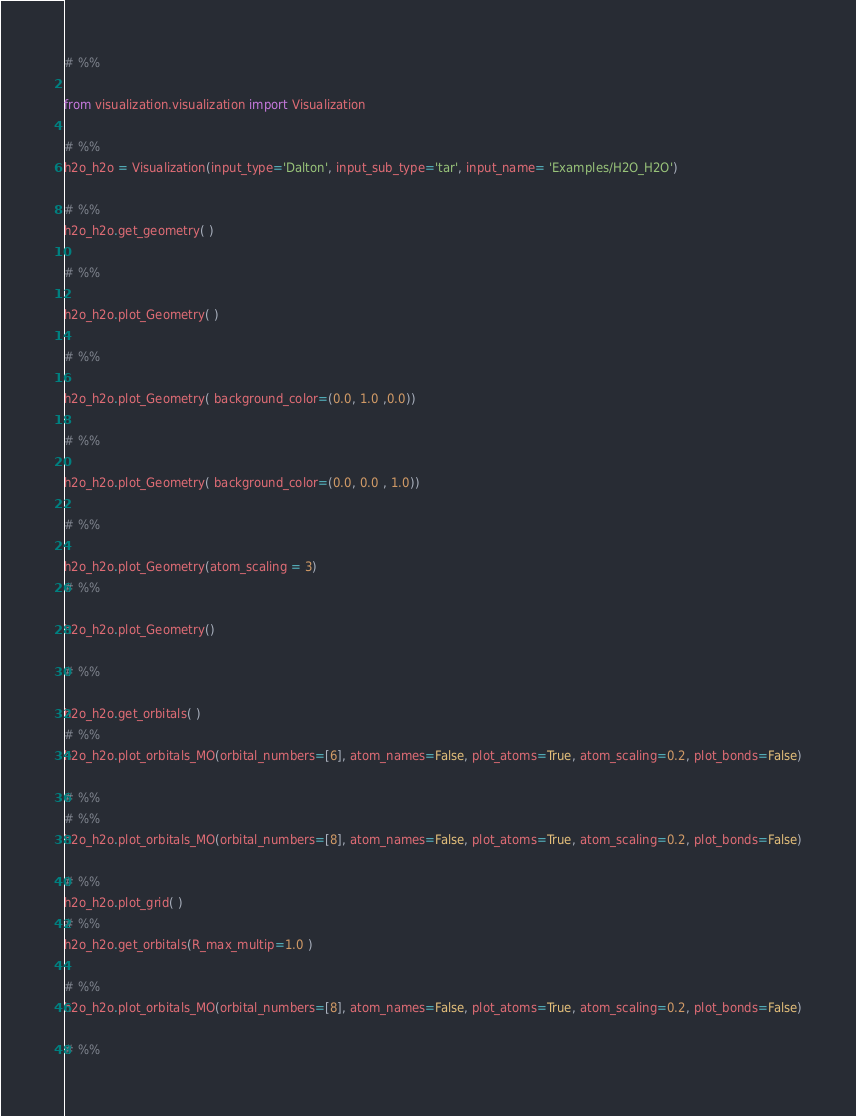<code> <loc_0><loc_0><loc_500><loc_500><_Python_># %% 

from visualization.visualization import Visualization

# %%
h2o_h2o = Visualization(input_type='Dalton', input_sub_type='tar', input_name= 'Examples/H2O_H2O')

# %%
h2o_h2o.get_geometry( )

# %%

h2o_h2o.plot_Geometry( )

# %%

h2o_h2o.plot_Geometry( background_color=(0.0, 1.0 ,0.0))

# %%

h2o_h2o.plot_Geometry( background_color=(0.0, 0.0 , 1.0))

# %%

h2o_h2o.plot_Geometry(atom_scaling = 3)
# %%

h2o_h2o.plot_Geometry()

# %%

h2o_h2o.get_orbitals( )
# %%
h2o_h2o.plot_orbitals_MO(orbital_numbers=[6], atom_names=False, plot_atoms=True, atom_scaling=0.2, plot_bonds=False)

# %%
# %%
h2o_h2o.plot_orbitals_MO(orbital_numbers=[8], atom_names=False, plot_atoms=True, atom_scaling=0.2, plot_bonds=False)

# %%
h2o_h2o.plot_grid( )
# %%
h2o_h2o.get_orbitals(R_max_multip=1.0 )

# %%
h2o_h2o.plot_orbitals_MO(orbital_numbers=[8], atom_names=False, plot_atoms=True, atom_scaling=0.2, plot_bonds=False)

# %%
</code> 